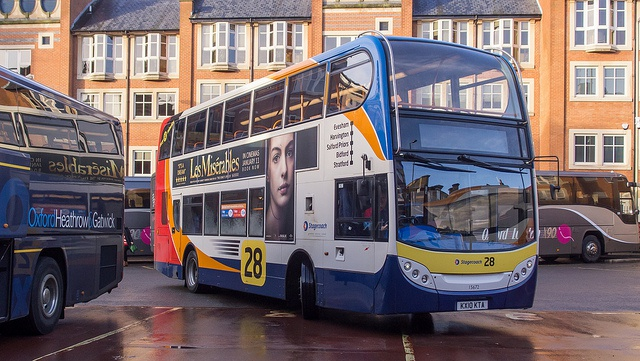Describe the objects in this image and their specific colors. I can see bus in navy, black, gray, and darkgray tones, bus in navy, black, gray, and darkgray tones, bus in navy, black, and gray tones, people in navy, gray, pink, and darkgray tones, and bus in navy, black, and gray tones in this image. 